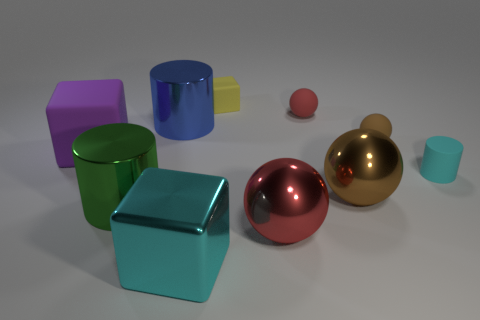Subtract all red rubber balls. How many balls are left? 3 Subtract all green cylinders. How many cylinders are left? 2 Subtract all balls. How many objects are left? 6 Subtract all yellow cubes. How many red spheres are left? 2 Add 1 brown objects. How many brown objects exist? 3 Subtract 0 brown cylinders. How many objects are left? 10 Subtract 1 cylinders. How many cylinders are left? 2 Subtract all gray balls. Subtract all red cubes. How many balls are left? 4 Subtract all blue metal things. Subtract all big green metal objects. How many objects are left? 8 Add 7 tiny rubber cylinders. How many tiny rubber cylinders are left? 8 